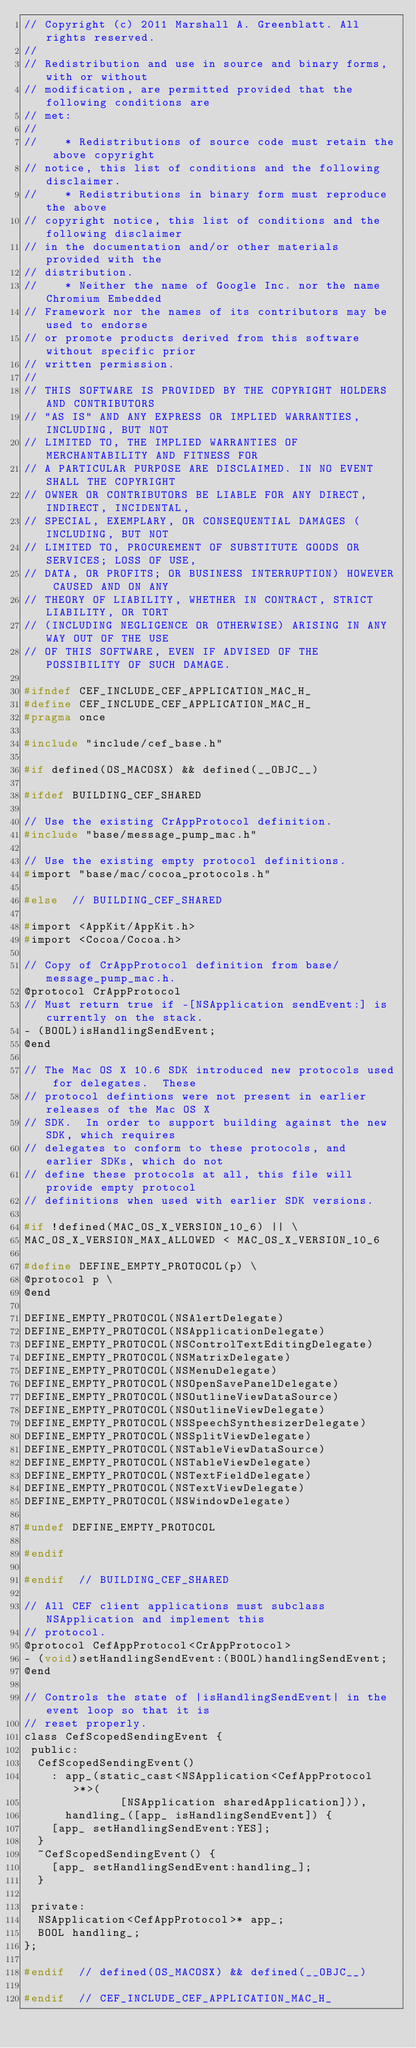<code> <loc_0><loc_0><loc_500><loc_500><_C_>// Copyright (c) 2011 Marshall A. Greenblatt. All rights reserved.
//
// Redistribution and use in source and binary forms, with or without
// modification, are permitted provided that the following conditions are
// met:
//
//    * Redistributions of source code must retain the above copyright
// notice, this list of conditions and the following disclaimer.
//    * Redistributions in binary form must reproduce the above
// copyright notice, this list of conditions and the following disclaimer
// in the documentation and/or other materials provided with the
// distribution.
//    * Neither the name of Google Inc. nor the name Chromium Embedded
// Framework nor the names of its contributors may be used to endorse
// or promote products derived from this software without specific prior
// written permission.
//
// THIS SOFTWARE IS PROVIDED BY THE COPYRIGHT HOLDERS AND CONTRIBUTORS
// "AS IS" AND ANY EXPRESS OR IMPLIED WARRANTIES, INCLUDING, BUT NOT
// LIMITED TO, THE IMPLIED WARRANTIES OF MERCHANTABILITY AND FITNESS FOR
// A PARTICULAR PURPOSE ARE DISCLAIMED. IN NO EVENT SHALL THE COPYRIGHT
// OWNER OR CONTRIBUTORS BE LIABLE FOR ANY DIRECT, INDIRECT, INCIDENTAL,
// SPECIAL, EXEMPLARY, OR CONSEQUENTIAL DAMAGES (INCLUDING, BUT NOT
// LIMITED TO, PROCUREMENT OF SUBSTITUTE GOODS OR SERVICES; LOSS OF USE,
// DATA, OR PROFITS; OR BUSINESS INTERRUPTION) HOWEVER CAUSED AND ON ANY
// THEORY OF LIABILITY, WHETHER IN CONTRACT, STRICT LIABILITY, OR TORT
// (INCLUDING NEGLIGENCE OR OTHERWISE) ARISING IN ANY WAY OUT OF THE USE
// OF THIS SOFTWARE, EVEN IF ADVISED OF THE POSSIBILITY OF SUCH DAMAGE.

#ifndef CEF_INCLUDE_CEF_APPLICATION_MAC_H_
#define CEF_INCLUDE_CEF_APPLICATION_MAC_H_
#pragma once

#include "include/cef_base.h"

#if defined(OS_MACOSX) && defined(__OBJC__)

#ifdef BUILDING_CEF_SHARED

// Use the existing CrAppProtocol definition.
#include "base/message_pump_mac.h"

// Use the existing empty protocol definitions.
#import "base/mac/cocoa_protocols.h"

#else  // BUILDING_CEF_SHARED

#import <AppKit/AppKit.h>
#import <Cocoa/Cocoa.h>

// Copy of CrAppProtocol definition from base/message_pump_mac.h.
@protocol CrAppProtocol
// Must return true if -[NSApplication sendEvent:] is currently on the stack.
- (BOOL)isHandlingSendEvent;
@end

// The Mac OS X 10.6 SDK introduced new protocols used for delegates.  These
// protocol defintions were not present in earlier releases of the Mac OS X
// SDK.  In order to support building against the new SDK, which requires
// delegates to conform to these protocols, and earlier SDKs, which do not
// define these protocols at all, this file will provide empty protocol
// definitions when used with earlier SDK versions.

#if !defined(MAC_OS_X_VERSION_10_6) || \
MAC_OS_X_VERSION_MAX_ALLOWED < MAC_OS_X_VERSION_10_6

#define DEFINE_EMPTY_PROTOCOL(p) \
@protocol p \
@end

DEFINE_EMPTY_PROTOCOL(NSAlertDelegate)
DEFINE_EMPTY_PROTOCOL(NSApplicationDelegate)
DEFINE_EMPTY_PROTOCOL(NSControlTextEditingDelegate)
DEFINE_EMPTY_PROTOCOL(NSMatrixDelegate)
DEFINE_EMPTY_PROTOCOL(NSMenuDelegate)
DEFINE_EMPTY_PROTOCOL(NSOpenSavePanelDelegate)
DEFINE_EMPTY_PROTOCOL(NSOutlineViewDataSource)
DEFINE_EMPTY_PROTOCOL(NSOutlineViewDelegate)
DEFINE_EMPTY_PROTOCOL(NSSpeechSynthesizerDelegate)
DEFINE_EMPTY_PROTOCOL(NSSplitViewDelegate)
DEFINE_EMPTY_PROTOCOL(NSTableViewDataSource)
DEFINE_EMPTY_PROTOCOL(NSTableViewDelegate)
DEFINE_EMPTY_PROTOCOL(NSTextFieldDelegate)
DEFINE_EMPTY_PROTOCOL(NSTextViewDelegate)
DEFINE_EMPTY_PROTOCOL(NSWindowDelegate)

#undef DEFINE_EMPTY_PROTOCOL

#endif

#endif  // BUILDING_CEF_SHARED

// All CEF client applications must subclass NSApplication and implement this
// protocol.
@protocol CefAppProtocol<CrAppProtocol>
- (void)setHandlingSendEvent:(BOOL)handlingSendEvent;
@end

// Controls the state of |isHandlingSendEvent| in the event loop so that it is
// reset properly.
class CefScopedSendingEvent {
 public:
  CefScopedSendingEvent()
    : app_(static_cast<NSApplication<CefAppProtocol>*>(
              [NSApplication sharedApplication])),
      handling_([app_ isHandlingSendEvent]) {
    [app_ setHandlingSendEvent:YES];
  }
  ~CefScopedSendingEvent() {
    [app_ setHandlingSendEvent:handling_];
  }

 private:
  NSApplication<CefAppProtocol>* app_;
  BOOL handling_;
};

#endif  // defined(OS_MACOSX) && defined(__OBJC__)

#endif  // CEF_INCLUDE_CEF_APPLICATION_MAC_H_
</code> 